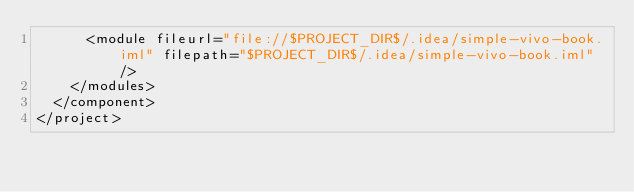<code> <loc_0><loc_0><loc_500><loc_500><_XML_>      <module fileurl="file://$PROJECT_DIR$/.idea/simple-vivo-book.iml" filepath="$PROJECT_DIR$/.idea/simple-vivo-book.iml" />
    </modules>
  </component>
</project>

</code> 